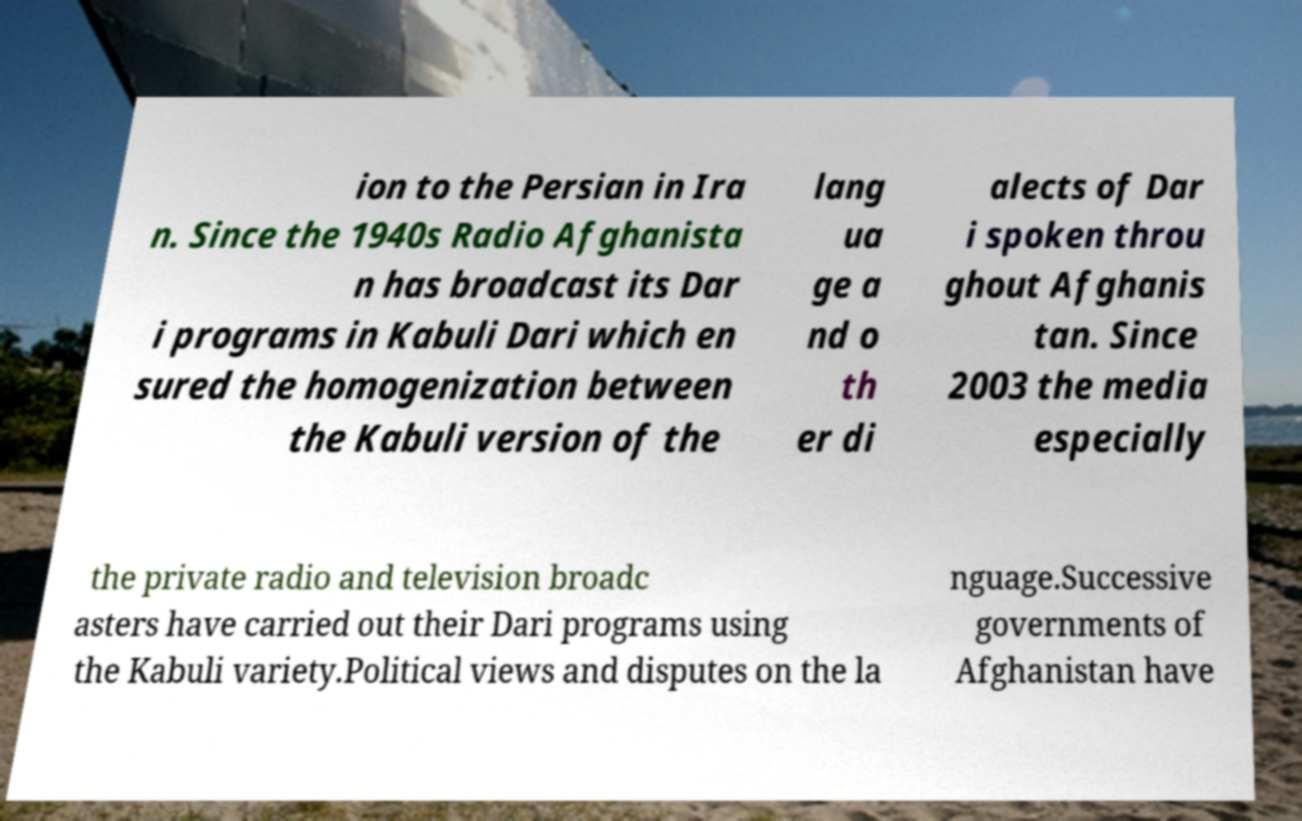Could you assist in decoding the text presented in this image and type it out clearly? ion to the Persian in Ira n. Since the 1940s Radio Afghanista n has broadcast its Dar i programs in Kabuli Dari which en sured the homogenization between the Kabuli version of the lang ua ge a nd o th er di alects of Dar i spoken throu ghout Afghanis tan. Since 2003 the media especially the private radio and television broadc asters have carried out their Dari programs using the Kabuli variety.Political views and disputes on the la nguage.Successive governments of Afghanistan have 